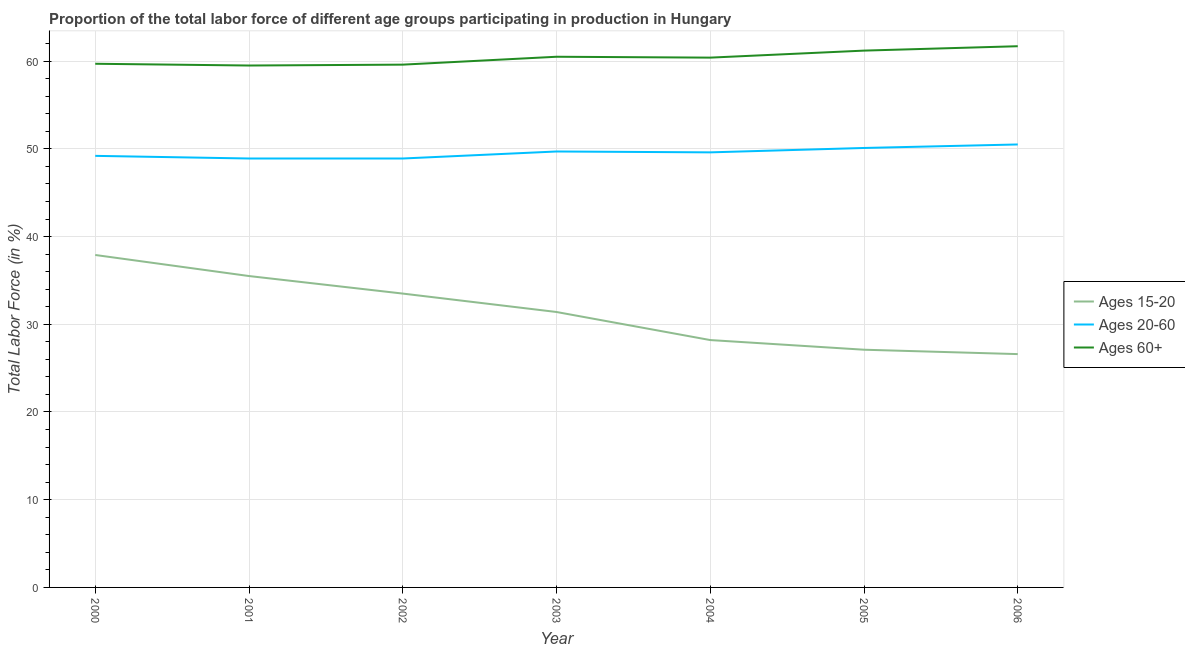How many different coloured lines are there?
Make the answer very short. 3. Is the number of lines equal to the number of legend labels?
Your response must be concise. Yes. What is the percentage of labor force within the age group 15-20 in 2000?
Provide a short and direct response. 37.9. Across all years, what is the maximum percentage of labor force above age 60?
Your answer should be compact. 61.7. Across all years, what is the minimum percentage of labor force within the age group 20-60?
Ensure brevity in your answer.  48.9. In which year was the percentage of labor force within the age group 20-60 maximum?
Provide a succinct answer. 2006. What is the total percentage of labor force within the age group 20-60 in the graph?
Make the answer very short. 346.9. What is the difference between the percentage of labor force within the age group 15-20 in 2004 and that in 2006?
Offer a terse response. 1.6. What is the difference between the percentage of labor force above age 60 in 2001 and the percentage of labor force within the age group 15-20 in 2003?
Provide a short and direct response. 28.1. What is the average percentage of labor force above age 60 per year?
Offer a terse response. 60.37. In the year 2002, what is the difference between the percentage of labor force above age 60 and percentage of labor force within the age group 20-60?
Make the answer very short. 10.7. What is the ratio of the percentage of labor force within the age group 20-60 in 2000 to that in 2004?
Your response must be concise. 0.99. Is the difference between the percentage of labor force within the age group 20-60 in 2002 and 2006 greater than the difference between the percentage of labor force above age 60 in 2002 and 2006?
Make the answer very short. Yes. What is the difference between the highest and the second highest percentage of labor force within the age group 20-60?
Offer a very short reply. 0.4. What is the difference between the highest and the lowest percentage of labor force above age 60?
Provide a short and direct response. 2.2. In how many years, is the percentage of labor force above age 60 greater than the average percentage of labor force above age 60 taken over all years?
Offer a very short reply. 4. Does the percentage of labor force above age 60 monotonically increase over the years?
Your answer should be very brief. No. Is the percentage of labor force above age 60 strictly greater than the percentage of labor force within the age group 15-20 over the years?
Your response must be concise. Yes. Is the percentage of labor force within the age group 20-60 strictly less than the percentage of labor force within the age group 15-20 over the years?
Make the answer very short. No. How many lines are there?
Make the answer very short. 3. How many years are there in the graph?
Provide a succinct answer. 7. What is the difference between two consecutive major ticks on the Y-axis?
Provide a succinct answer. 10. Are the values on the major ticks of Y-axis written in scientific E-notation?
Your response must be concise. No. Does the graph contain any zero values?
Your answer should be compact. No. Does the graph contain grids?
Your answer should be compact. Yes. How many legend labels are there?
Give a very brief answer. 3. What is the title of the graph?
Your answer should be compact. Proportion of the total labor force of different age groups participating in production in Hungary. Does "Infant(female)" appear as one of the legend labels in the graph?
Provide a short and direct response. No. What is the label or title of the X-axis?
Your answer should be very brief. Year. What is the Total Labor Force (in %) in Ages 15-20 in 2000?
Keep it short and to the point. 37.9. What is the Total Labor Force (in %) of Ages 20-60 in 2000?
Keep it short and to the point. 49.2. What is the Total Labor Force (in %) in Ages 60+ in 2000?
Your answer should be compact. 59.7. What is the Total Labor Force (in %) of Ages 15-20 in 2001?
Offer a very short reply. 35.5. What is the Total Labor Force (in %) in Ages 20-60 in 2001?
Your answer should be compact. 48.9. What is the Total Labor Force (in %) of Ages 60+ in 2001?
Your answer should be very brief. 59.5. What is the Total Labor Force (in %) of Ages 15-20 in 2002?
Make the answer very short. 33.5. What is the Total Labor Force (in %) in Ages 20-60 in 2002?
Provide a short and direct response. 48.9. What is the Total Labor Force (in %) of Ages 60+ in 2002?
Give a very brief answer. 59.6. What is the Total Labor Force (in %) of Ages 15-20 in 2003?
Your answer should be very brief. 31.4. What is the Total Labor Force (in %) in Ages 20-60 in 2003?
Your response must be concise. 49.7. What is the Total Labor Force (in %) in Ages 60+ in 2003?
Keep it short and to the point. 60.5. What is the Total Labor Force (in %) of Ages 15-20 in 2004?
Your answer should be very brief. 28.2. What is the Total Labor Force (in %) in Ages 20-60 in 2004?
Your answer should be very brief. 49.6. What is the Total Labor Force (in %) of Ages 60+ in 2004?
Offer a terse response. 60.4. What is the Total Labor Force (in %) in Ages 15-20 in 2005?
Your answer should be very brief. 27.1. What is the Total Labor Force (in %) in Ages 20-60 in 2005?
Offer a very short reply. 50.1. What is the Total Labor Force (in %) in Ages 60+ in 2005?
Ensure brevity in your answer.  61.2. What is the Total Labor Force (in %) of Ages 15-20 in 2006?
Your answer should be compact. 26.6. What is the Total Labor Force (in %) of Ages 20-60 in 2006?
Make the answer very short. 50.5. What is the Total Labor Force (in %) of Ages 60+ in 2006?
Provide a succinct answer. 61.7. Across all years, what is the maximum Total Labor Force (in %) in Ages 15-20?
Provide a short and direct response. 37.9. Across all years, what is the maximum Total Labor Force (in %) in Ages 20-60?
Keep it short and to the point. 50.5. Across all years, what is the maximum Total Labor Force (in %) in Ages 60+?
Give a very brief answer. 61.7. Across all years, what is the minimum Total Labor Force (in %) in Ages 15-20?
Ensure brevity in your answer.  26.6. Across all years, what is the minimum Total Labor Force (in %) in Ages 20-60?
Your response must be concise. 48.9. Across all years, what is the minimum Total Labor Force (in %) of Ages 60+?
Offer a very short reply. 59.5. What is the total Total Labor Force (in %) of Ages 15-20 in the graph?
Your answer should be compact. 220.2. What is the total Total Labor Force (in %) in Ages 20-60 in the graph?
Make the answer very short. 346.9. What is the total Total Labor Force (in %) in Ages 60+ in the graph?
Offer a very short reply. 422.6. What is the difference between the Total Labor Force (in %) of Ages 15-20 in 2000 and that in 2001?
Offer a very short reply. 2.4. What is the difference between the Total Labor Force (in %) in Ages 20-60 in 2000 and that in 2001?
Offer a terse response. 0.3. What is the difference between the Total Labor Force (in %) of Ages 60+ in 2000 and that in 2001?
Offer a very short reply. 0.2. What is the difference between the Total Labor Force (in %) of Ages 60+ in 2000 and that in 2003?
Ensure brevity in your answer.  -0.8. What is the difference between the Total Labor Force (in %) of Ages 20-60 in 2000 and that in 2004?
Your answer should be very brief. -0.4. What is the difference between the Total Labor Force (in %) in Ages 60+ in 2000 and that in 2004?
Ensure brevity in your answer.  -0.7. What is the difference between the Total Labor Force (in %) of Ages 20-60 in 2000 and that in 2005?
Your response must be concise. -0.9. What is the difference between the Total Labor Force (in %) in Ages 60+ in 2000 and that in 2005?
Keep it short and to the point. -1.5. What is the difference between the Total Labor Force (in %) of Ages 15-20 in 2000 and that in 2006?
Keep it short and to the point. 11.3. What is the difference between the Total Labor Force (in %) in Ages 15-20 in 2001 and that in 2002?
Your answer should be compact. 2. What is the difference between the Total Labor Force (in %) of Ages 20-60 in 2001 and that in 2002?
Your response must be concise. 0. What is the difference between the Total Labor Force (in %) of Ages 60+ in 2001 and that in 2002?
Provide a short and direct response. -0.1. What is the difference between the Total Labor Force (in %) of Ages 15-20 in 2001 and that in 2003?
Provide a short and direct response. 4.1. What is the difference between the Total Labor Force (in %) in Ages 20-60 in 2001 and that in 2003?
Provide a short and direct response. -0.8. What is the difference between the Total Labor Force (in %) of Ages 15-20 in 2001 and that in 2005?
Offer a very short reply. 8.4. What is the difference between the Total Labor Force (in %) in Ages 20-60 in 2001 and that in 2005?
Provide a short and direct response. -1.2. What is the difference between the Total Labor Force (in %) of Ages 20-60 in 2001 and that in 2006?
Provide a succinct answer. -1.6. What is the difference between the Total Labor Force (in %) in Ages 60+ in 2001 and that in 2006?
Ensure brevity in your answer.  -2.2. What is the difference between the Total Labor Force (in %) of Ages 20-60 in 2002 and that in 2004?
Your response must be concise. -0.7. What is the difference between the Total Labor Force (in %) of Ages 60+ in 2002 and that in 2004?
Provide a succinct answer. -0.8. What is the difference between the Total Labor Force (in %) in Ages 15-20 in 2002 and that in 2005?
Your answer should be very brief. 6.4. What is the difference between the Total Labor Force (in %) in Ages 20-60 in 2002 and that in 2005?
Keep it short and to the point. -1.2. What is the difference between the Total Labor Force (in %) in Ages 15-20 in 2002 and that in 2006?
Your answer should be compact. 6.9. What is the difference between the Total Labor Force (in %) in Ages 20-60 in 2002 and that in 2006?
Make the answer very short. -1.6. What is the difference between the Total Labor Force (in %) in Ages 60+ in 2002 and that in 2006?
Keep it short and to the point. -2.1. What is the difference between the Total Labor Force (in %) of Ages 15-20 in 2003 and that in 2005?
Your response must be concise. 4.3. What is the difference between the Total Labor Force (in %) in Ages 20-60 in 2003 and that in 2005?
Your answer should be compact. -0.4. What is the difference between the Total Labor Force (in %) in Ages 15-20 in 2003 and that in 2006?
Your response must be concise. 4.8. What is the difference between the Total Labor Force (in %) of Ages 20-60 in 2003 and that in 2006?
Provide a succinct answer. -0.8. What is the difference between the Total Labor Force (in %) in Ages 20-60 in 2004 and that in 2006?
Provide a succinct answer. -0.9. What is the difference between the Total Labor Force (in %) of Ages 15-20 in 2000 and the Total Labor Force (in %) of Ages 60+ in 2001?
Make the answer very short. -21.6. What is the difference between the Total Labor Force (in %) of Ages 20-60 in 2000 and the Total Labor Force (in %) of Ages 60+ in 2001?
Your response must be concise. -10.3. What is the difference between the Total Labor Force (in %) in Ages 15-20 in 2000 and the Total Labor Force (in %) in Ages 20-60 in 2002?
Provide a short and direct response. -11. What is the difference between the Total Labor Force (in %) of Ages 15-20 in 2000 and the Total Labor Force (in %) of Ages 60+ in 2002?
Your response must be concise. -21.7. What is the difference between the Total Labor Force (in %) of Ages 20-60 in 2000 and the Total Labor Force (in %) of Ages 60+ in 2002?
Give a very brief answer. -10.4. What is the difference between the Total Labor Force (in %) in Ages 15-20 in 2000 and the Total Labor Force (in %) in Ages 60+ in 2003?
Keep it short and to the point. -22.6. What is the difference between the Total Labor Force (in %) of Ages 20-60 in 2000 and the Total Labor Force (in %) of Ages 60+ in 2003?
Offer a terse response. -11.3. What is the difference between the Total Labor Force (in %) in Ages 15-20 in 2000 and the Total Labor Force (in %) in Ages 60+ in 2004?
Offer a very short reply. -22.5. What is the difference between the Total Labor Force (in %) in Ages 20-60 in 2000 and the Total Labor Force (in %) in Ages 60+ in 2004?
Offer a very short reply. -11.2. What is the difference between the Total Labor Force (in %) in Ages 15-20 in 2000 and the Total Labor Force (in %) in Ages 20-60 in 2005?
Offer a very short reply. -12.2. What is the difference between the Total Labor Force (in %) in Ages 15-20 in 2000 and the Total Labor Force (in %) in Ages 60+ in 2005?
Make the answer very short. -23.3. What is the difference between the Total Labor Force (in %) of Ages 20-60 in 2000 and the Total Labor Force (in %) of Ages 60+ in 2005?
Give a very brief answer. -12. What is the difference between the Total Labor Force (in %) in Ages 15-20 in 2000 and the Total Labor Force (in %) in Ages 60+ in 2006?
Your response must be concise. -23.8. What is the difference between the Total Labor Force (in %) in Ages 20-60 in 2000 and the Total Labor Force (in %) in Ages 60+ in 2006?
Your response must be concise. -12.5. What is the difference between the Total Labor Force (in %) of Ages 15-20 in 2001 and the Total Labor Force (in %) of Ages 60+ in 2002?
Your answer should be compact. -24.1. What is the difference between the Total Labor Force (in %) in Ages 15-20 in 2001 and the Total Labor Force (in %) in Ages 60+ in 2003?
Your answer should be compact. -25. What is the difference between the Total Labor Force (in %) in Ages 20-60 in 2001 and the Total Labor Force (in %) in Ages 60+ in 2003?
Offer a terse response. -11.6. What is the difference between the Total Labor Force (in %) in Ages 15-20 in 2001 and the Total Labor Force (in %) in Ages 20-60 in 2004?
Keep it short and to the point. -14.1. What is the difference between the Total Labor Force (in %) in Ages 15-20 in 2001 and the Total Labor Force (in %) in Ages 60+ in 2004?
Provide a succinct answer. -24.9. What is the difference between the Total Labor Force (in %) in Ages 20-60 in 2001 and the Total Labor Force (in %) in Ages 60+ in 2004?
Make the answer very short. -11.5. What is the difference between the Total Labor Force (in %) in Ages 15-20 in 2001 and the Total Labor Force (in %) in Ages 20-60 in 2005?
Make the answer very short. -14.6. What is the difference between the Total Labor Force (in %) in Ages 15-20 in 2001 and the Total Labor Force (in %) in Ages 60+ in 2005?
Offer a very short reply. -25.7. What is the difference between the Total Labor Force (in %) in Ages 20-60 in 2001 and the Total Labor Force (in %) in Ages 60+ in 2005?
Your answer should be very brief. -12.3. What is the difference between the Total Labor Force (in %) of Ages 15-20 in 2001 and the Total Labor Force (in %) of Ages 60+ in 2006?
Offer a very short reply. -26.2. What is the difference between the Total Labor Force (in %) of Ages 15-20 in 2002 and the Total Labor Force (in %) of Ages 20-60 in 2003?
Offer a very short reply. -16.2. What is the difference between the Total Labor Force (in %) in Ages 15-20 in 2002 and the Total Labor Force (in %) in Ages 60+ in 2003?
Offer a terse response. -27. What is the difference between the Total Labor Force (in %) of Ages 15-20 in 2002 and the Total Labor Force (in %) of Ages 20-60 in 2004?
Ensure brevity in your answer.  -16.1. What is the difference between the Total Labor Force (in %) in Ages 15-20 in 2002 and the Total Labor Force (in %) in Ages 60+ in 2004?
Offer a very short reply. -26.9. What is the difference between the Total Labor Force (in %) in Ages 20-60 in 2002 and the Total Labor Force (in %) in Ages 60+ in 2004?
Offer a terse response. -11.5. What is the difference between the Total Labor Force (in %) in Ages 15-20 in 2002 and the Total Labor Force (in %) in Ages 20-60 in 2005?
Offer a terse response. -16.6. What is the difference between the Total Labor Force (in %) of Ages 15-20 in 2002 and the Total Labor Force (in %) of Ages 60+ in 2005?
Give a very brief answer. -27.7. What is the difference between the Total Labor Force (in %) of Ages 15-20 in 2002 and the Total Labor Force (in %) of Ages 60+ in 2006?
Ensure brevity in your answer.  -28.2. What is the difference between the Total Labor Force (in %) of Ages 15-20 in 2003 and the Total Labor Force (in %) of Ages 20-60 in 2004?
Provide a short and direct response. -18.2. What is the difference between the Total Labor Force (in %) of Ages 20-60 in 2003 and the Total Labor Force (in %) of Ages 60+ in 2004?
Offer a terse response. -10.7. What is the difference between the Total Labor Force (in %) of Ages 15-20 in 2003 and the Total Labor Force (in %) of Ages 20-60 in 2005?
Your response must be concise. -18.7. What is the difference between the Total Labor Force (in %) in Ages 15-20 in 2003 and the Total Labor Force (in %) in Ages 60+ in 2005?
Ensure brevity in your answer.  -29.8. What is the difference between the Total Labor Force (in %) of Ages 20-60 in 2003 and the Total Labor Force (in %) of Ages 60+ in 2005?
Offer a very short reply. -11.5. What is the difference between the Total Labor Force (in %) in Ages 15-20 in 2003 and the Total Labor Force (in %) in Ages 20-60 in 2006?
Keep it short and to the point. -19.1. What is the difference between the Total Labor Force (in %) of Ages 15-20 in 2003 and the Total Labor Force (in %) of Ages 60+ in 2006?
Offer a very short reply. -30.3. What is the difference between the Total Labor Force (in %) of Ages 20-60 in 2003 and the Total Labor Force (in %) of Ages 60+ in 2006?
Offer a very short reply. -12. What is the difference between the Total Labor Force (in %) of Ages 15-20 in 2004 and the Total Labor Force (in %) of Ages 20-60 in 2005?
Provide a succinct answer. -21.9. What is the difference between the Total Labor Force (in %) of Ages 15-20 in 2004 and the Total Labor Force (in %) of Ages 60+ in 2005?
Your answer should be very brief. -33. What is the difference between the Total Labor Force (in %) of Ages 20-60 in 2004 and the Total Labor Force (in %) of Ages 60+ in 2005?
Your response must be concise. -11.6. What is the difference between the Total Labor Force (in %) in Ages 15-20 in 2004 and the Total Labor Force (in %) in Ages 20-60 in 2006?
Your answer should be very brief. -22.3. What is the difference between the Total Labor Force (in %) in Ages 15-20 in 2004 and the Total Labor Force (in %) in Ages 60+ in 2006?
Your answer should be compact. -33.5. What is the difference between the Total Labor Force (in %) in Ages 20-60 in 2004 and the Total Labor Force (in %) in Ages 60+ in 2006?
Provide a succinct answer. -12.1. What is the difference between the Total Labor Force (in %) in Ages 15-20 in 2005 and the Total Labor Force (in %) in Ages 20-60 in 2006?
Provide a short and direct response. -23.4. What is the difference between the Total Labor Force (in %) in Ages 15-20 in 2005 and the Total Labor Force (in %) in Ages 60+ in 2006?
Offer a terse response. -34.6. What is the average Total Labor Force (in %) of Ages 15-20 per year?
Ensure brevity in your answer.  31.46. What is the average Total Labor Force (in %) of Ages 20-60 per year?
Offer a very short reply. 49.56. What is the average Total Labor Force (in %) in Ages 60+ per year?
Keep it short and to the point. 60.37. In the year 2000, what is the difference between the Total Labor Force (in %) in Ages 15-20 and Total Labor Force (in %) in Ages 60+?
Your answer should be compact. -21.8. In the year 2000, what is the difference between the Total Labor Force (in %) in Ages 20-60 and Total Labor Force (in %) in Ages 60+?
Give a very brief answer. -10.5. In the year 2001, what is the difference between the Total Labor Force (in %) in Ages 15-20 and Total Labor Force (in %) in Ages 60+?
Provide a succinct answer. -24. In the year 2001, what is the difference between the Total Labor Force (in %) in Ages 20-60 and Total Labor Force (in %) in Ages 60+?
Your answer should be compact. -10.6. In the year 2002, what is the difference between the Total Labor Force (in %) of Ages 15-20 and Total Labor Force (in %) of Ages 20-60?
Your answer should be compact. -15.4. In the year 2002, what is the difference between the Total Labor Force (in %) in Ages 15-20 and Total Labor Force (in %) in Ages 60+?
Offer a terse response. -26.1. In the year 2002, what is the difference between the Total Labor Force (in %) in Ages 20-60 and Total Labor Force (in %) in Ages 60+?
Make the answer very short. -10.7. In the year 2003, what is the difference between the Total Labor Force (in %) of Ages 15-20 and Total Labor Force (in %) of Ages 20-60?
Your answer should be compact. -18.3. In the year 2003, what is the difference between the Total Labor Force (in %) of Ages 15-20 and Total Labor Force (in %) of Ages 60+?
Give a very brief answer. -29.1. In the year 2003, what is the difference between the Total Labor Force (in %) of Ages 20-60 and Total Labor Force (in %) of Ages 60+?
Your answer should be compact. -10.8. In the year 2004, what is the difference between the Total Labor Force (in %) in Ages 15-20 and Total Labor Force (in %) in Ages 20-60?
Give a very brief answer. -21.4. In the year 2004, what is the difference between the Total Labor Force (in %) of Ages 15-20 and Total Labor Force (in %) of Ages 60+?
Your response must be concise. -32.2. In the year 2005, what is the difference between the Total Labor Force (in %) in Ages 15-20 and Total Labor Force (in %) in Ages 60+?
Give a very brief answer. -34.1. In the year 2006, what is the difference between the Total Labor Force (in %) in Ages 15-20 and Total Labor Force (in %) in Ages 20-60?
Your response must be concise. -23.9. In the year 2006, what is the difference between the Total Labor Force (in %) of Ages 15-20 and Total Labor Force (in %) of Ages 60+?
Offer a very short reply. -35.1. In the year 2006, what is the difference between the Total Labor Force (in %) of Ages 20-60 and Total Labor Force (in %) of Ages 60+?
Your answer should be very brief. -11.2. What is the ratio of the Total Labor Force (in %) in Ages 15-20 in 2000 to that in 2001?
Make the answer very short. 1.07. What is the ratio of the Total Labor Force (in %) of Ages 60+ in 2000 to that in 2001?
Provide a short and direct response. 1. What is the ratio of the Total Labor Force (in %) in Ages 15-20 in 2000 to that in 2002?
Provide a succinct answer. 1.13. What is the ratio of the Total Labor Force (in %) of Ages 60+ in 2000 to that in 2002?
Keep it short and to the point. 1. What is the ratio of the Total Labor Force (in %) of Ages 15-20 in 2000 to that in 2003?
Give a very brief answer. 1.21. What is the ratio of the Total Labor Force (in %) in Ages 60+ in 2000 to that in 2003?
Keep it short and to the point. 0.99. What is the ratio of the Total Labor Force (in %) of Ages 15-20 in 2000 to that in 2004?
Offer a very short reply. 1.34. What is the ratio of the Total Labor Force (in %) of Ages 60+ in 2000 to that in 2004?
Offer a terse response. 0.99. What is the ratio of the Total Labor Force (in %) of Ages 15-20 in 2000 to that in 2005?
Ensure brevity in your answer.  1.4. What is the ratio of the Total Labor Force (in %) in Ages 20-60 in 2000 to that in 2005?
Provide a succinct answer. 0.98. What is the ratio of the Total Labor Force (in %) of Ages 60+ in 2000 to that in 2005?
Keep it short and to the point. 0.98. What is the ratio of the Total Labor Force (in %) in Ages 15-20 in 2000 to that in 2006?
Provide a succinct answer. 1.42. What is the ratio of the Total Labor Force (in %) in Ages 20-60 in 2000 to that in 2006?
Your answer should be compact. 0.97. What is the ratio of the Total Labor Force (in %) in Ages 60+ in 2000 to that in 2006?
Provide a succinct answer. 0.97. What is the ratio of the Total Labor Force (in %) in Ages 15-20 in 2001 to that in 2002?
Keep it short and to the point. 1.06. What is the ratio of the Total Labor Force (in %) of Ages 20-60 in 2001 to that in 2002?
Provide a succinct answer. 1. What is the ratio of the Total Labor Force (in %) in Ages 15-20 in 2001 to that in 2003?
Give a very brief answer. 1.13. What is the ratio of the Total Labor Force (in %) in Ages 20-60 in 2001 to that in 2003?
Your response must be concise. 0.98. What is the ratio of the Total Labor Force (in %) in Ages 60+ in 2001 to that in 2003?
Keep it short and to the point. 0.98. What is the ratio of the Total Labor Force (in %) in Ages 15-20 in 2001 to that in 2004?
Provide a succinct answer. 1.26. What is the ratio of the Total Labor Force (in %) of Ages 20-60 in 2001 to that in 2004?
Offer a terse response. 0.99. What is the ratio of the Total Labor Force (in %) of Ages 60+ in 2001 to that in 2004?
Your answer should be compact. 0.99. What is the ratio of the Total Labor Force (in %) in Ages 15-20 in 2001 to that in 2005?
Your answer should be very brief. 1.31. What is the ratio of the Total Labor Force (in %) of Ages 60+ in 2001 to that in 2005?
Give a very brief answer. 0.97. What is the ratio of the Total Labor Force (in %) in Ages 15-20 in 2001 to that in 2006?
Provide a short and direct response. 1.33. What is the ratio of the Total Labor Force (in %) of Ages 20-60 in 2001 to that in 2006?
Give a very brief answer. 0.97. What is the ratio of the Total Labor Force (in %) of Ages 15-20 in 2002 to that in 2003?
Offer a terse response. 1.07. What is the ratio of the Total Labor Force (in %) in Ages 20-60 in 2002 to that in 2003?
Your answer should be very brief. 0.98. What is the ratio of the Total Labor Force (in %) in Ages 60+ in 2002 to that in 2003?
Keep it short and to the point. 0.99. What is the ratio of the Total Labor Force (in %) in Ages 15-20 in 2002 to that in 2004?
Your answer should be compact. 1.19. What is the ratio of the Total Labor Force (in %) in Ages 20-60 in 2002 to that in 2004?
Offer a terse response. 0.99. What is the ratio of the Total Labor Force (in %) of Ages 60+ in 2002 to that in 2004?
Provide a short and direct response. 0.99. What is the ratio of the Total Labor Force (in %) in Ages 15-20 in 2002 to that in 2005?
Provide a short and direct response. 1.24. What is the ratio of the Total Labor Force (in %) of Ages 20-60 in 2002 to that in 2005?
Provide a succinct answer. 0.98. What is the ratio of the Total Labor Force (in %) in Ages 60+ in 2002 to that in 2005?
Provide a short and direct response. 0.97. What is the ratio of the Total Labor Force (in %) in Ages 15-20 in 2002 to that in 2006?
Keep it short and to the point. 1.26. What is the ratio of the Total Labor Force (in %) in Ages 20-60 in 2002 to that in 2006?
Make the answer very short. 0.97. What is the ratio of the Total Labor Force (in %) of Ages 15-20 in 2003 to that in 2004?
Provide a short and direct response. 1.11. What is the ratio of the Total Labor Force (in %) of Ages 15-20 in 2003 to that in 2005?
Your response must be concise. 1.16. What is the ratio of the Total Labor Force (in %) in Ages 60+ in 2003 to that in 2005?
Offer a terse response. 0.99. What is the ratio of the Total Labor Force (in %) in Ages 15-20 in 2003 to that in 2006?
Your answer should be very brief. 1.18. What is the ratio of the Total Labor Force (in %) in Ages 20-60 in 2003 to that in 2006?
Provide a short and direct response. 0.98. What is the ratio of the Total Labor Force (in %) of Ages 60+ in 2003 to that in 2006?
Your response must be concise. 0.98. What is the ratio of the Total Labor Force (in %) in Ages 15-20 in 2004 to that in 2005?
Provide a short and direct response. 1.04. What is the ratio of the Total Labor Force (in %) in Ages 20-60 in 2004 to that in 2005?
Make the answer very short. 0.99. What is the ratio of the Total Labor Force (in %) in Ages 60+ in 2004 to that in 2005?
Offer a terse response. 0.99. What is the ratio of the Total Labor Force (in %) in Ages 15-20 in 2004 to that in 2006?
Provide a short and direct response. 1.06. What is the ratio of the Total Labor Force (in %) of Ages 20-60 in 2004 to that in 2006?
Your response must be concise. 0.98. What is the ratio of the Total Labor Force (in %) of Ages 60+ in 2004 to that in 2006?
Give a very brief answer. 0.98. What is the ratio of the Total Labor Force (in %) in Ages 15-20 in 2005 to that in 2006?
Ensure brevity in your answer.  1.02. What is the ratio of the Total Labor Force (in %) of Ages 20-60 in 2005 to that in 2006?
Give a very brief answer. 0.99. What is the difference between the highest and the second highest Total Labor Force (in %) of Ages 15-20?
Your answer should be compact. 2.4. What is the difference between the highest and the second highest Total Labor Force (in %) in Ages 20-60?
Make the answer very short. 0.4. What is the difference between the highest and the second highest Total Labor Force (in %) in Ages 60+?
Your response must be concise. 0.5. What is the difference between the highest and the lowest Total Labor Force (in %) of Ages 20-60?
Your response must be concise. 1.6. What is the difference between the highest and the lowest Total Labor Force (in %) of Ages 60+?
Give a very brief answer. 2.2. 